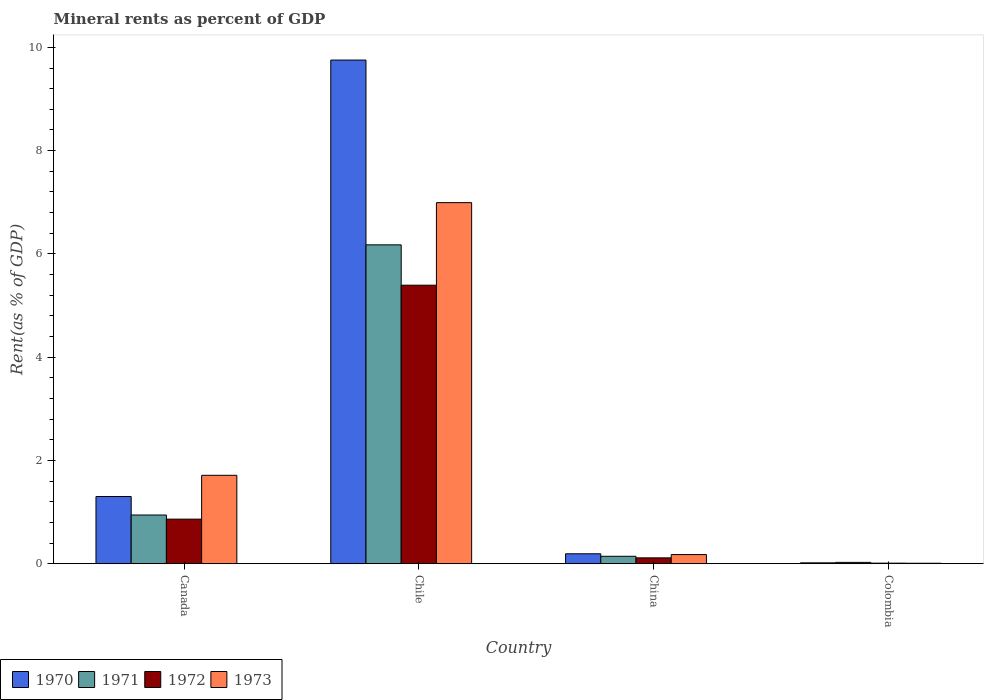How many groups of bars are there?
Make the answer very short. 4. Are the number of bars per tick equal to the number of legend labels?
Make the answer very short. Yes. How many bars are there on the 3rd tick from the left?
Offer a very short reply. 4. What is the label of the 2nd group of bars from the left?
Keep it short and to the point. Chile. What is the mineral rent in 1971 in Colombia?
Ensure brevity in your answer.  0.03. Across all countries, what is the maximum mineral rent in 1970?
Provide a succinct answer. 9.75. Across all countries, what is the minimum mineral rent in 1973?
Make the answer very short. 0.01. What is the total mineral rent in 1973 in the graph?
Give a very brief answer. 8.89. What is the difference between the mineral rent in 1973 in Canada and that in Colombia?
Give a very brief answer. 1.7. What is the difference between the mineral rent in 1973 in Chile and the mineral rent in 1971 in Colombia?
Ensure brevity in your answer.  6.97. What is the average mineral rent in 1971 per country?
Your response must be concise. 1.82. What is the difference between the mineral rent of/in 1970 and mineral rent of/in 1971 in China?
Your answer should be very brief. 0.05. In how many countries, is the mineral rent in 1972 greater than 3.6 %?
Keep it short and to the point. 1. What is the ratio of the mineral rent in 1972 in Canada to that in China?
Your answer should be compact. 7.61. Is the difference between the mineral rent in 1970 in China and Colombia greater than the difference between the mineral rent in 1971 in China and Colombia?
Offer a terse response. Yes. What is the difference between the highest and the second highest mineral rent in 1973?
Provide a short and direct response. -1.53. What is the difference between the highest and the lowest mineral rent in 1971?
Offer a very short reply. 6.15. Is it the case that in every country, the sum of the mineral rent in 1972 and mineral rent in 1971 is greater than the sum of mineral rent in 1973 and mineral rent in 1970?
Offer a very short reply. No. How many bars are there?
Give a very brief answer. 16. Does the graph contain grids?
Your answer should be very brief. No. Where does the legend appear in the graph?
Provide a short and direct response. Bottom left. How many legend labels are there?
Your answer should be very brief. 4. What is the title of the graph?
Keep it short and to the point. Mineral rents as percent of GDP. Does "1994" appear as one of the legend labels in the graph?
Provide a succinct answer. No. What is the label or title of the Y-axis?
Offer a very short reply. Rent(as % of GDP). What is the Rent(as % of GDP) in 1970 in Canada?
Give a very brief answer. 1.3. What is the Rent(as % of GDP) in 1971 in Canada?
Keep it short and to the point. 0.94. What is the Rent(as % of GDP) of 1972 in Canada?
Make the answer very short. 0.86. What is the Rent(as % of GDP) in 1973 in Canada?
Your answer should be compact. 1.71. What is the Rent(as % of GDP) in 1970 in Chile?
Offer a terse response. 9.75. What is the Rent(as % of GDP) of 1971 in Chile?
Your answer should be compact. 6.18. What is the Rent(as % of GDP) of 1972 in Chile?
Offer a terse response. 5.39. What is the Rent(as % of GDP) in 1973 in Chile?
Ensure brevity in your answer.  6.99. What is the Rent(as % of GDP) in 1970 in China?
Ensure brevity in your answer.  0.19. What is the Rent(as % of GDP) of 1971 in China?
Offer a terse response. 0.14. What is the Rent(as % of GDP) of 1972 in China?
Provide a succinct answer. 0.11. What is the Rent(as % of GDP) of 1973 in China?
Keep it short and to the point. 0.18. What is the Rent(as % of GDP) in 1970 in Colombia?
Your answer should be compact. 0.02. What is the Rent(as % of GDP) of 1971 in Colombia?
Your answer should be very brief. 0.03. What is the Rent(as % of GDP) in 1972 in Colombia?
Provide a succinct answer. 0.01. What is the Rent(as % of GDP) of 1973 in Colombia?
Ensure brevity in your answer.  0.01. Across all countries, what is the maximum Rent(as % of GDP) of 1970?
Offer a very short reply. 9.75. Across all countries, what is the maximum Rent(as % of GDP) of 1971?
Provide a succinct answer. 6.18. Across all countries, what is the maximum Rent(as % of GDP) of 1972?
Keep it short and to the point. 5.39. Across all countries, what is the maximum Rent(as % of GDP) in 1973?
Offer a very short reply. 6.99. Across all countries, what is the minimum Rent(as % of GDP) of 1970?
Offer a terse response. 0.02. Across all countries, what is the minimum Rent(as % of GDP) in 1971?
Provide a succinct answer. 0.03. Across all countries, what is the minimum Rent(as % of GDP) of 1972?
Keep it short and to the point. 0.01. Across all countries, what is the minimum Rent(as % of GDP) in 1973?
Offer a terse response. 0.01. What is the total Rent(as % of GDP) in 1970 in the graph?
Keep it short and to the point. 11.27. What is the total Rent(as % of GDP) of 1971 in the graph?
Your answer should be compact. 7.29. What is the total Rent(as % of GDP) of 1972 in the graph?
Provide a succinct answer. 6.38. What is the total Rent(as % of GDP) in 1973 in the graph?
Make the answer very short. 8.89. What is the difference between the Rent(as % of GDP) of 1970 in Canada and that in Chile?
Your answer should be very brief. -8.45. What is the difference between the Rent(as % of GDP) of 1971 in Canada and that in Chile?
Give a very brief answer. -5.23. What is the difference between the Rent(as % of GDP) in 1972 in Canada and that in Chile?
Provide a short and direct response. -4.53. What is the difference between the Rent(as % of GDP) of 1973 in Canada and that in Chile?
Provide a short and direct response. -5.28. What is the difference between the Rent(as % of GDP) of 1970 in Canada and that in China?
Make the answer very short. 1.11. What is the difference between the Rent(as % of GDP) of 1971 in Canada and that in China?
Provide a short and direct response. 0.8. What is the difference between the Rent(as % of GDP) in 1972 in Canada and that in China?
Make the answer very short. 0.75. What is the difference between the Rent(as % of GDP) of 1973 in Canada and that in China?
Offer a terse response. 1.53. What is the difference between the Rent(as % of GDP) in 1970 in Canada and that in Colombia?
Offer a terse response. 1.28. What is the difference between the Rent(as % of GDP) of 1971 in Canada and that in Colombia?
Keep it short and to the point. 0.92. What is the difference between the Rent(as % of GDP) of 1972 in Canada and that in Colombia?
Your answer should be compact. 0.85. What is the difference between the Rent(as % of GDP) in 1973 in Canada and that in Colombia?
Provide a short and direct response. 1.7. What is the difference between the Rent(as % of GDP) of 1970 in Chile and that in China?
Your response must be concise. 9.56. What is the difference between the Rent(as % of GDP) in 1971 in Chile and that in China?
Make the answer very short. 6.03. What is the difference between the Rent(as % of GDP) in 1972 in Chile and that in China?
Ensure brevity in your answer.  5.28. What is the difference between the Rent(as % of GDP) in 1973 in Chile and that in China?
Provide a succinct answer. 6.82. What is the difference between the Rent(as % of GDP) in 1970 in Chile and that in Colombia?
Your answer should be compact. 9.74. What is the difference between the Rent(as % of GDP) of 1971 in Chile and that in Colombia?
Offer a very short reply. 6.15. What is the difference between the Rent(as % of GDP) of 1972 in Chile and that in Colombia?
Offer a terse response. 5.38. What is the difference between the Rent(as % of GDP) in 1973 in Chile and that in Colombia?
Provide a short and direct response. 6.98. What is the difference between the Rent(as % of GDP) of 1970 in China and that in Colombia?
Ensure brevity in your answer.  0.18. What is the difference between the Rent(as % of GDP) of 1971 in China and that in Colombia?
Offer a very short reply. 0.12. What is the difference between the Rent(as % of GDP) of 1972 in China and that in Colombia?
Offer a terse response. 0.1. What is the difference between the Rent(as % of GDP) in 1973 in China and that in Colombia?
Ensure brevity in your answer.  0.17. What is the difference between the Rent(as % of GDP) of 1970 in Canada and the Rent(as % of GDP) of 1971 in Chile?
Provide a succinct answer. -4.87. What is the difference between the Rent(as % of GDP) in 1970 in Canada and the Rent(as % of GDP) in 1972 in Chile?
Give a very brief answer. -4.09. What is the difference between the Rent(as % of GDP) in 1970 in Canada and the Rent(as % of GDP) in 1973 in Chile?
Provide a succinct answer. -5.69. What is the difference between the Rent(as % of GDP) of 1971 in Canada and the Rent(as % of GDP) of 1972 in Chile?
Your answer should be very brief. -4.45. What is the difference between the Rent(as % of GDP) in 1971 in Canada and the Rent(as % of GDP) in 1973 in Chile?
Provide a succinct answer. -6.05. What is the difference between the Rent(as % of GDP) in 1972 in Canada and the Rent(as % of GDP) in 1973 in Chile?
Make the answer very short. -6.13. What is the difference between the Rent(as % of GDP) in 1970 in Canada and the Rent(as % of GDP) in 1971 in China?
Provide a short and direct response. 1.16. What is the difference between the Rent(as % of GDP) of 1970 in Canada and the Rent(as % of GDP) of 1972 in China?
Make the answer very short. 1.19. What is the difference between the Rent(as % of GDP) in 1970 in Canada and the Rent(as % of GDP) in 1973 in China?
Provide a short and direct response. 1.12. What is the difference between the Rent(as % of GDP) of 1971 in Canada and the Rent(as % of GDP) of 1972 in China?
Your answer should be very brief. 0.83. What is the difference between the Rent(as % of GDP) in 1971 in Canada and the Rent(as % of GDP) in 1973 in China?
Give a very brief answer. 0.77. What is the difference between the Rent(as % of GDP) in 1972 in Canada and the Rent(as % of GDP) in 1973 in China?
Your response must be concise. 0.69. What is the difference between the Rent(as % of GDP) of 1970 in Canada and the Rent(as % of GDP) of 1971 in Colombia?
Keep it short and to the point. 1.28. What is the difference between the Rent(as % of GDP) of 1970 in Canada and the Rent(as % of GDP) of 1972 in Colombia?
Your answer should be very brief. 1.29. What is the difference between the Rent(as % of GDP) in 1970 in Canada and the Rent(as % of GDP) in 1973 in Colombia?
Give a very brief answer. 1.29. What is the difference between the Rent(as % of GDP) in 1971 in Canada and the Rent(as % of GDP) in 1972 in Colombia?
Give a very brief answer. 0.93. What is the difference between the Rent(as % of GDP) of 1971 in Canada and the Rent(as % of GDP) of 1973 in Colombia?
Give a very brief answer. 0.93. What is the difference between the Rent(as % of GDP) of 1972 in Canada and the Rent(as % of GDP) of 1973 in Colombia?
Make the answer very short. 0.85. What is the difference between the Rent(as % of GDP) of 1970 in Chile and the Rent(as % of GDP) of 1971 in China?
Provide a succinct answer. 9.61. What is the difference between the Rent(as % of GDP) of 1970 in Chile and the Rent(as % of GDP) of 1972 in China?
Your answer should be very brief. 9.64. What is the difference between the Rent(as % of GDP) in 1970 in Chile and the Rent(as % of GDP) in 1973 in China?
Offer a very short reply. 9.58. What is the difference between the Rent(as % of GDP) of 1971 in Chile and the Rent(as % of GDP) of 1972 in China?
Provide a succinct answer. 6.06. What is the difference between the Rent(as % of GDP) in 1971 in Chile and the Rent(as % of GDP) in 1973 in China?
Offer a very short reply. 6. What is the difference between the Rent(as % of GDP) in 1972 in Chile and the Rent(as % of GDP) in 1973 in China?
Keep it short and to the point. 5.22. What is the difference between the Rent(as % of GDP) in 1970 in Chile and the Rent(as % of GDP) in 1971 in Colombia?
Provide a succinct answer. 9.73. What is the difference between the Rent(as % of GDP) in 1970 in Chile and the Rent(as % of GDP) in 1972 in Colombia?
Your answer should be compact. 9.74. What is the difference between the Rent(as % of GDP) of 1970 in Chile and the Rent(as % of GDP) of 1973 in Colombia?
Keep it short and to the point. 9.74. What is the difference between the Rent(as % of GDP) in 1971 in Chile and the Rent(as % of GDP) in 1972 in Colombia?
Your answer should be compact. 6.16. What is the difference between the Rent(as % of GDP) in 1971 in Chile and the Rent(as % of GDP) in 1973 in Colombia?
Give a very brief answer. 6.17. What is the difference between the Rent(as % of GDP) of 1972 in Chile and the Rent(as % of GDP) of 1973 in Colombia?
Your response must be concise. 5.38. What is the difference between the Rent(as % of GDP) in 1970 in China and the Rent(as % of GDP) in 1971 in Colombia?
Ensure brevity in your answer.  0.17. What is the difference between the Rent(as % of GDP) of 1970 in China and the Rent(as % of GDP) of 1972 in Colombia?
Your answer should be very brief. 0.18. What is the difference between the Rent(as % of GDP) of 1970 in China and the Rent(as % of GDP) of 1973 in Colombia?
Provide a short and direct response. 0.18. What is the difference between the Rent(as % of GDP) of 1971 in China and the Rent(as % of GDP) of 1972 in Colombia?
Offer a very short reply. 0.13. What is the difference between the Rent(as % of GDP) in 1971 in China and the Rent(as % of GDP) in 1973 in Colombia?
Ensure brevity in your answer.  0.13. What is the difference between the Rent(as % of GDP) of 1972 in China and the Rent(as % of GDP) of 1973 in Colombia?
Your response must be concise. 0.1. What is the average Rent(as % of GDP) in 1970 per country?
Provide a short and direct response. 2.82. What is the average Rent(as % of GDP) of 1971 per country?
Your answer should be very brief. 1.82. What is the average Rent(as % of GDP) of 1972 per country?
Your answer should be very brief. 1.6. What is the average Rent(as % of GDP) of 1973 per country?
Make the answer very short. 2.22. What is the difference between the Rent(as % of GDP) of 1970 and Rent(as % of GDP) of 1971 in Canada?
Your response must be concise. 0.36. What is the difference between the Rent(as % of GDP) of 1970 and Rent(as % of GDP) of 1972 in Canada?
Offer a very short reply. 0.44. What is the difference between the Rent(as % of GDP) in 1970 and Rent(as % of GDP) in 1973 in Canada?
Offer a terse response. -0.41. What is the difference between the Rent(as % of GDP) in 1971 and Rent(as % of GDP) in 1972 in Canada?
Provide a succinct answer. 0.08. What is the difference between the Rent(as % of GDP) of 1971 and Rent(as % of GDP) of 1973 in Canada?
Offer a very short reply. -0.77. What is the difference between the Rent(as % of GDP) in 1972 and Rent(as % of GDP) in 1973 in Canada?
Ensure brevity in your answer.  -0.85. What is the difference between the Rent(as % of GDP) of 1970 and Rent(as % of GDP) of 1971 in Chile?
Give a very brief answer. 3.58. What is the difference between the Rent(as % of GDP) in 1970 and Rent(as % of GDP) in 1972 in Chile?
Provide a succinct answer. 4.36. What is the difference between the Rent(as % of GDP) in 1970 and Rent(as % of GDP) in 1973 in Chile?
Keep it short and to the point. 2.76. What is the difference between the Rent(as % of GDP) of 1971 and Rent(as % of GDP) of 1972 in Chile?
Your response must be concise. 0.78. What is the difference between the Rent(as % of GDP) in 1971 and Rent(as % of GDP) in 1973 in Chile?
Your answer should be very brief. -0.82. What is the difference between the Rent(as % of GDP) of 1972 and Rent(as % of GDP) of 1973 in Chile?
Provide a short and direct response. -1.6. What is the difference between the Rent(as % of GDP) of 1970 and Rent(as % of GDP) of 1971 in China?
Provide a succinct answer. 0.05. What is the difference between the Rent(as % of GDP) in 1970 and Rent(as % of GDP) in 1972 in China?
Provide a succinct answer. 0.08. What is the difference between the Rent(as % of GDP) in 1970 and Rent(as % of GDP) in 1973 in China?
Provide a succinct answer. 0.02. What is the difference between the Rent(as % of GDP) of 1971 and Rent(as % of GDP) of 1972 in China?
Offer a very short reply. 0.03. What is the difference between the Rent(as % of GDP) in 1971 and Rent(as % of GDP) in 1973 in China?
Give a very brief answer. -0.03. What is the difference between the Rent(as % of GDP) in 1972 and Rent(as % of GDP) in 1973 in China?
Offer a terse response. -0.06. What is the difference between the Rent(as % of GDP) in 1970 and Rent(as % of GDP) in 1971 in Colombia?
Your answer should be compact. -0.01. What is the difference between the Rent(as % of GDP) of 1970 and Rent(as % of GDP) of 1972 in Colombia?
Your answer should be compact. 0.01. What is the difference between the Rent(as % of GDP) of 1970 and Rent(as % of GDP) of 1973 in Colombia?
Provide a succinct answer. 0.01. What is the difference between the Rent(as % of GDP) of 1971 and Rent(as % of GDP) of 1972 in Colombia?
Your answer should be compact. 0.01. What is the difference between the Rent(as % of GDP) of 1971 and Rent(as % of GDP) of 1973 in Colombia?
Offer a very short reply. 0.02. What is the difference between the Rent(as % of GDP) of 1972 and Rent(as % of GDP) of 1973 in Colombia?
Keep it short and to the point. 0. What is the ratio of the Rent(as % of GDP) of 1970 in Canada to that in Chile?
Your answer should be very brief. 0.13. What is the ratio of the Rent(as % of GDP) of 1971 in Canada to that in Chile?
Offer a very short reply. 0.15. What is the ratio of the Rent(as % of GDP) of 1972 in Canada to that in Chile?
Ensure brevity in your answer.  0.16. What is the ratio of the Rent(as % of GDP) in 1973 in Canada to that in Chile?
Your answer should be very brief. 0.24. What is the ratio of the Rent(as % of GDP) of 1970 in Canada to that in China?
Your answer should be compact. 6.76. What is the ratio of the Rent(as % of GDP) of 1971 in Canada to that in China?
Offer a very short reply. 6.54. What is the ratio of the Rent(as % of GDP) in 1972 in Canada to that in China?
Your answer should be very brief. 7.61. What is the ratio of the Rent(as % of GDP) of 1973 in Canada to that in China?
Provide a short and direct response. 9.65. What is the ratio of the Rent(as % of GDP) of 1970 in Canada to that in Colombia?
Offer a very short reply. 75.77. What is the ratio of the Rent(as % of GDP) in 1971 in Canada to that in Colombia?
Offer a terse response. 36.15. What is the ratio of the Rent(as % of GDP) of 1972 in Canada to that in Colombia?
Ensure brevity in your answer.  77.46. What is the ratio of the Rent(as % of GDP) in 1973 in Canada to that in Colombia?
Your response must be concise. 183.14. What is the ratio of the Rent(as % of GDP) in 1970 in Chile to that in China?
Provide a succinct answer. 50.65. What is the ratio of the Rent(as % of GDP) in 1971 in Chile to that in China?
Provide a short and direct response. 42.82. What is the ratio of the Rent(as % of GDP) in 1972 in Chile to that in China?
Offer a terse response. 47.55. What is the ratio of the Rent(as % of GDP) in 1973 in Chile to that in China?
Keep it short and to the point. 39.41. What is the ratio of the Rent(as % of GDP) in 1970 in Chile to that in Colombia?
Offer a terse response. 567.75. What is the ratio of the Rent(as % of GDP) in 1971 in Chile to that in Colombia?
Ensure brevity in your answer.  236.61. What is the ratio of the Rent(as % of GDP) of 1972 in Chile to that in Colombia?
Your response must be concise. 483.8. What is the ratio of the Rent(as % of GDP) in 1973 in Chile to that in Colombia?
Your answer should be compact. 747.96. What is the ratio of the Rent(as % of GDP) of 1970 in China to that in Colombia?
Make the answer very short. 11.21. What is the ratio of the Rent(as % of GDP) of 1971 in China to that in Colombia?
Offer a very short reply. 5.53. What is the ratio of the Rent(as % of GDP) of 1972 in China to that in Colombia?
Your answer should be very brief. 10.17. What is the ratio of the Rent(as % of GDP) in 1973 in China to that in Colombia?
Give a very brief answer. 18.98. What is the difference between the highest and the second highest Rent(as % of GDP) in 1970?
Your answer should be very brief. 8.45. What is the difference between the highest and the second highest Rent(as % of GDP) in 1971?
Keep it short and to the point. 5.23. What is the difference between the highest and the second highest Rent(as % of GDP) in 1972?
Give a very brief answer. 4.53. What is the difference between the highest and the second highest Rent(as % of GDP) of 1973?
Offer a very short reply. 5.28. What is the difference between the highest and the lowest Rent(as % of GDP) of 1970?
Your answer should be compact. 9.74. What is the difference between the highest and the lowest Rent(as % of GDP) in 1971?
Make the answer very short. 6.15. What is the difference between the highest and the lowest Rent(as % of GDP) of 1972?
Provide a short and direct response. 5.38. What is the difference between the highest and the lowest Rent(as % of GDP) of 1973?
Ensure brevity in your answer.  6.98. 